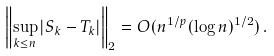Convert formula to latex. <formula><loc_0><loc_0><loc_500><loc_500>\left \| \sup _ { k \leq n } | S _ { k } - T _ { k } | \right \| _ { 2 } = O ( n ^ { 1 / p } ( \log n ) ^ { 1 / 2 } ) \, .</formula> 